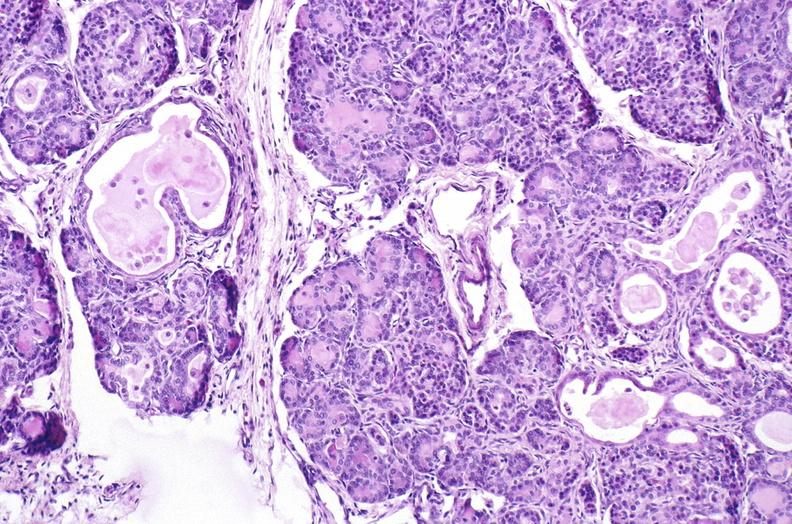what is present?
Answer the question using a single word or phrase. Pancreas 